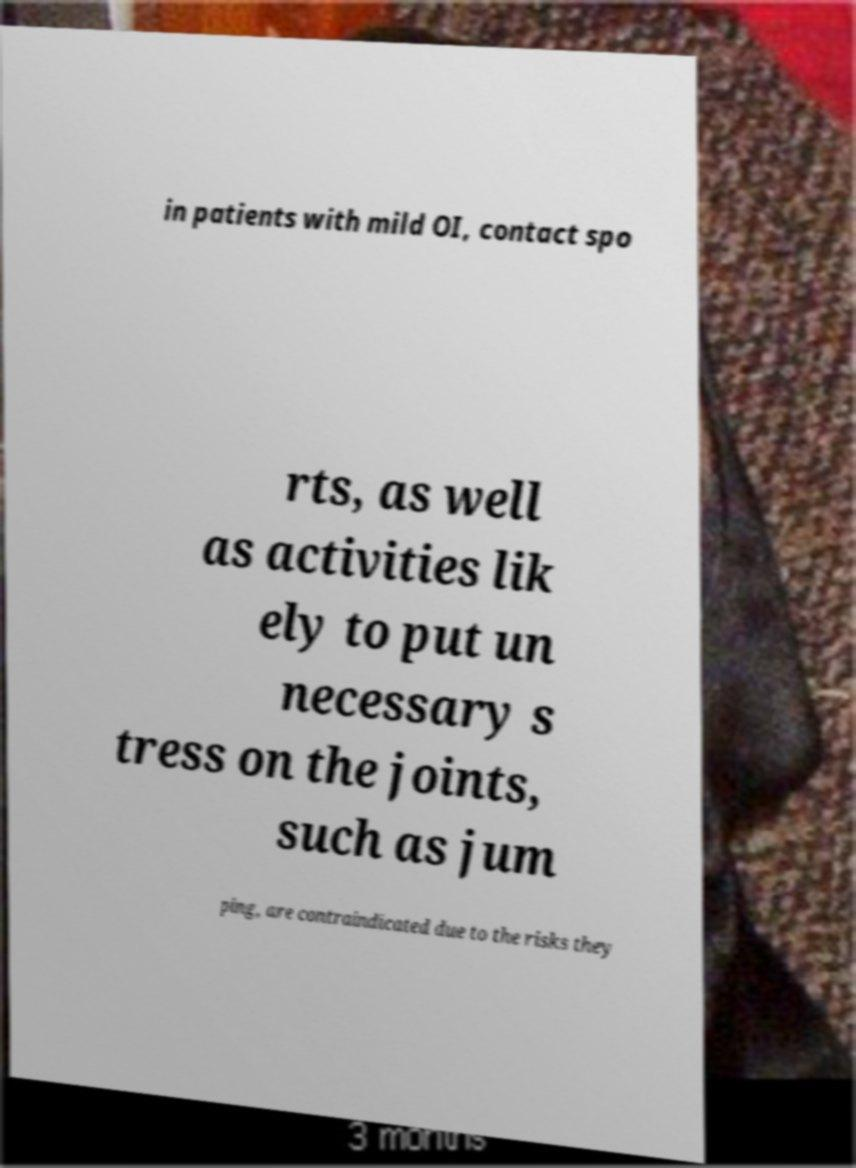Could you extract and type out the text from this image? in patients with mild OI, contact spo rts, as well as activities lik ely to put un necessary s tress on the joints, such as jum ping, are contraindicated due to the risks they 